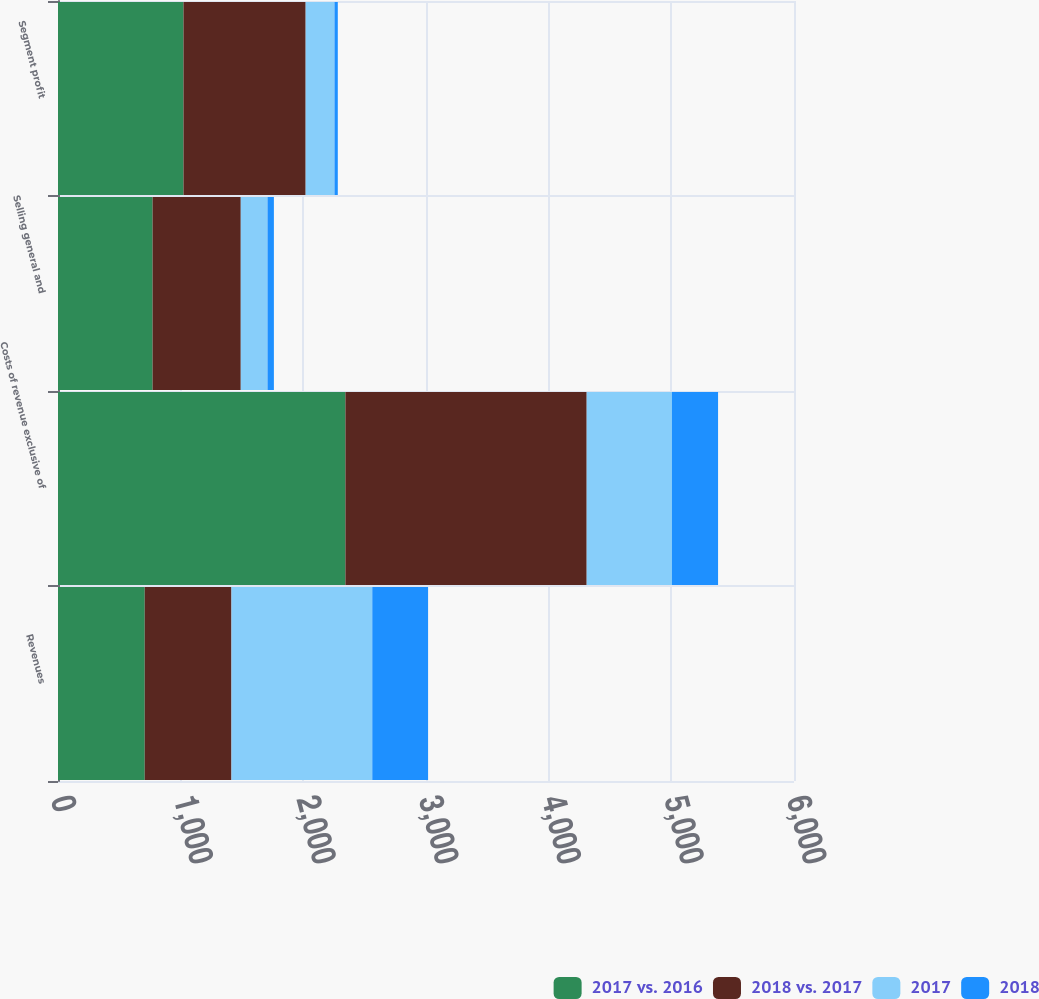<chart> <loc_0><loc_0><loc_500><loc_500><stacked_bar_chart><ecel><fcel>Revenues<fcel>Costs of revenue exclusive of<fcel>Selling general and<fcel>Segment profit<nl><fcel>2017 vs. 2016<fcel>707<fcel>2343<fcel>771<fcel>1023<nl><fcel>2018 vs. 2017<fcel>707<fcel>1967<fcel>719<fcel>996<nl><fcel>2017<fcel>1148<fcel>695<fcel>218<fcel>235<nl><fcel>2018<fcel>455<fcel>376<fcel>52<fcel>27<nl></chart> 